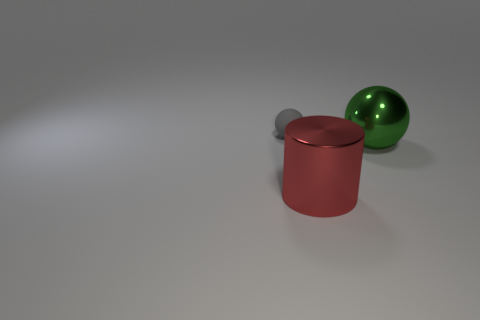Do the gray thing and the sphere that is right of the big red thing have the same material?
Provide a succinct answer. No. Is there a large green metal sphere to the left of the big object that is on the left side of the big green object?
Your response must be concise. No. There is a tiny gray thing that is the same shape as the big green thing; what is it made of?
Your answer should be very brief. Rubber. How many matte objects are on the left side of the sphere on the right side of the small thing?
Offer a very short reply. 1. Is there anything else of the same color as the small matte sphere?
Keep it short and to the point. No. What number of things are either big red metal things or big things to the left of the large green thing?
Make the answer very short. 1. What is the material of the sphere in front of the object that is behind the object that is on the right side of the large red metallic object?
Provide a short and direct response. Metal. There is a thing that is the same material as the big red cylinder; what is its size?
Make the answer very short. Large. The ball that is right of the sphere that is behind the big sphere is what color?
Your response must be concise. Green. How many large cylinders are made of the same material as the green ball?
Provide a succinct answer. 1. 